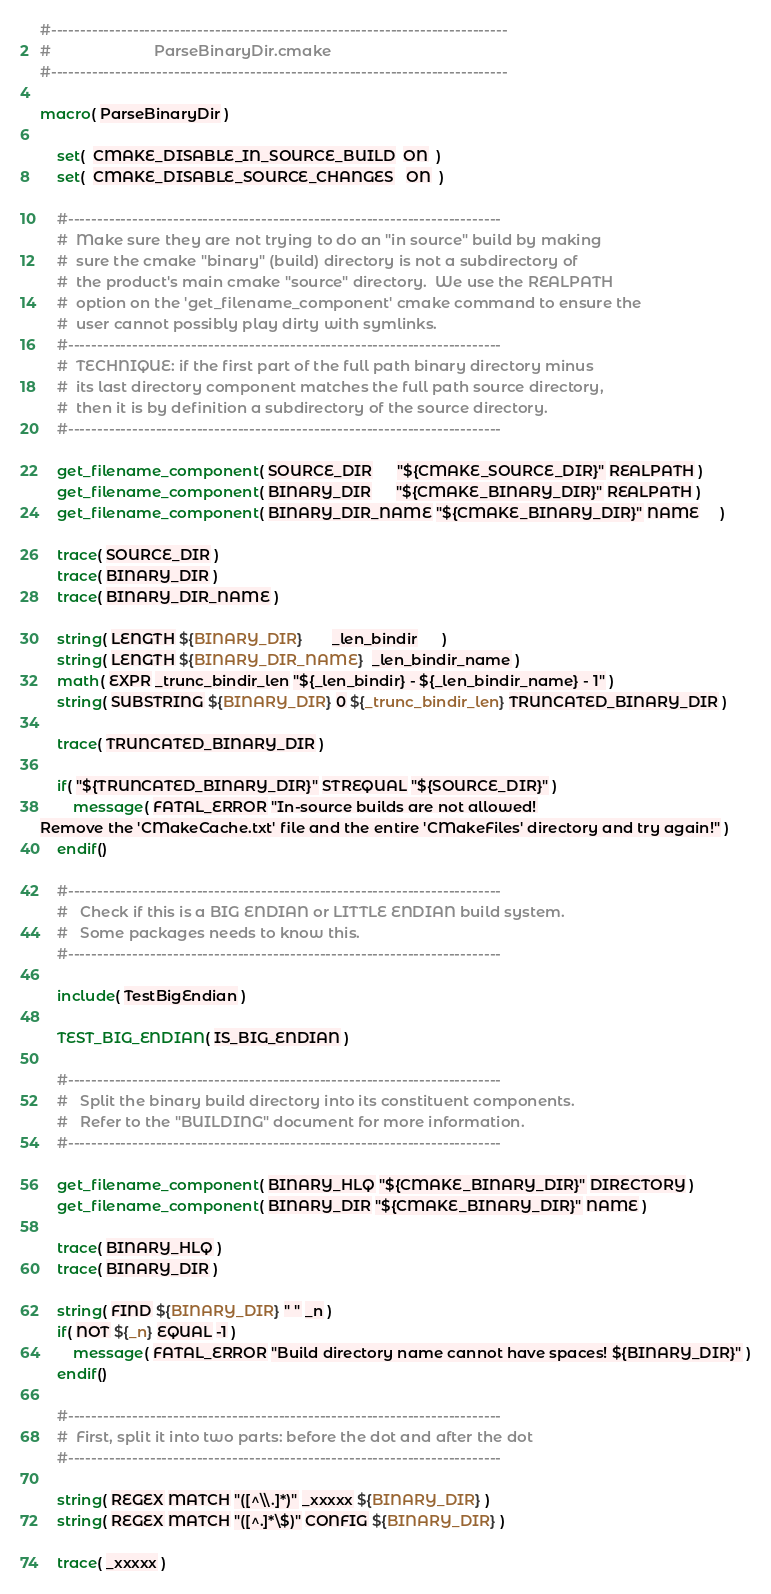Convert code to text. <code><loc_0><loc_0><loc_500><loc_500><_CMake_>#------------------------------------------------------------------------------
#                         ParseBinaryDir.cmake
#------------------------------------------------------------------------------

macro( ParseBinaryDir )

    set(  CMAKE_DISABLE_IN_SOURCE_BUILD  ON  )
    set(  CMAKE_DISABLE_SOURCE_CHANGES   ON  )

    #--------------------------------------------------------------------------
    #  Make sure they are not trying to do an "in source" build by making
    #  sure the cmake "binary" (build) directory is not a subdirectory of
    #  the product's main cmake "source" directory.  We use the REALPATH
    #  option on the 'get_filename_component' cmake command to ensure the
    #  user cannot possibly play dirty with symlinks.
    #--------------------------------------------------------------------------
    #  TECHNIQUE: if the first part of the full path binary directory minus
    #  its last directory component matches the full path source directory,
    #  then it is by definition a subdirectory of the source directory.
    #--------------------------------------------------------------------------

    get_filename_component( SOURCE_DIR      "${CMAKE_SOURCE_DIR}" REALPATH )
    get_filename_component( BINARY_DIR      "${CMAKE_BINARY_DIR}" REALPATH )
    get_filename_component( BINARY_DIR_NAME "${CMAKE_BINARY_DIR}" NAME     )

    trace( SOURCE_DIR )
    trace( BINARY_DIR )
    trace( BINARY_DIR_NAME )

    string( LENGTH ${BINARY_DIR}       _len_bindir      )
    string( LENGTH ${BINARY_DIR_NAME}  _len_bindir_name )
    math( EXPR _trunc_bindir_len "${_len_bindir} - ${_len_bindir_name} - 1" )
    string( SUBSTRING ${BINARY_DIR} 0 ${_trunc_bindir_len} TRUNCATED_BINARY_DIR )

    trace( TRUNCATED_BINARY_DIR )

    if( "${TRUNCATED_BINARY_DIR}" STREQUAL "${SOURCE_DIR}" )
        message( FATAL_ERROR "In-source builds are not allowed!
Remove the 'CMakeCache.txt' file and the entire 'CMakeFiles' directory and try again!" )
    endif()

    #--------------------------------------------------------------------------
    #   Check if this is a BIG ENDIAN or LITTLE ENDIAN build system.
    #   Some packages needs to know this.
    #--------------------------------------------------------------------------

    include( TestBigEndian )

    TEST_BIG_ENDIAN( IS_BIG_ENDIAN )

    #--------------------------------------------------------------------------
    #   Split the binary build directory into its constituent components.
    #   Refer to the "BUILDING" document for more information.
    #--------------------------------------------------------------------------

    get_filename_component( BINARY_HLQ "${CMAKE_BINARY_DIR}" DIRECTORY )
    get_filename_component( BINARY_DIR "${CMAKE_BINARY_DIR}" NAME )

    trace( BINARY_HLQ )
    trace( BINARY_DIR )

    string( FIND ${BINARY_DIR} " " _n )
    if( NOT ${_n} EQUAL -1 )
        message( FATAL_ERROR "Build directory name cannot have spaces! ${BINARY_DIR}" )
    endif()

    #--------------------------------------------------------------------------
    #  First, split it into two parts: before the dot and after the dot
    #--------------------------------------------------------------------------

    string( REGEX MATCH "([^\\.]*)" _xxxxx ${BINARY_DIR} )
    string( REGEX MATCH "([^.]*\$)" CONFIG ${BINARY_DIR} )

    trace( _xxxxx )</code> 